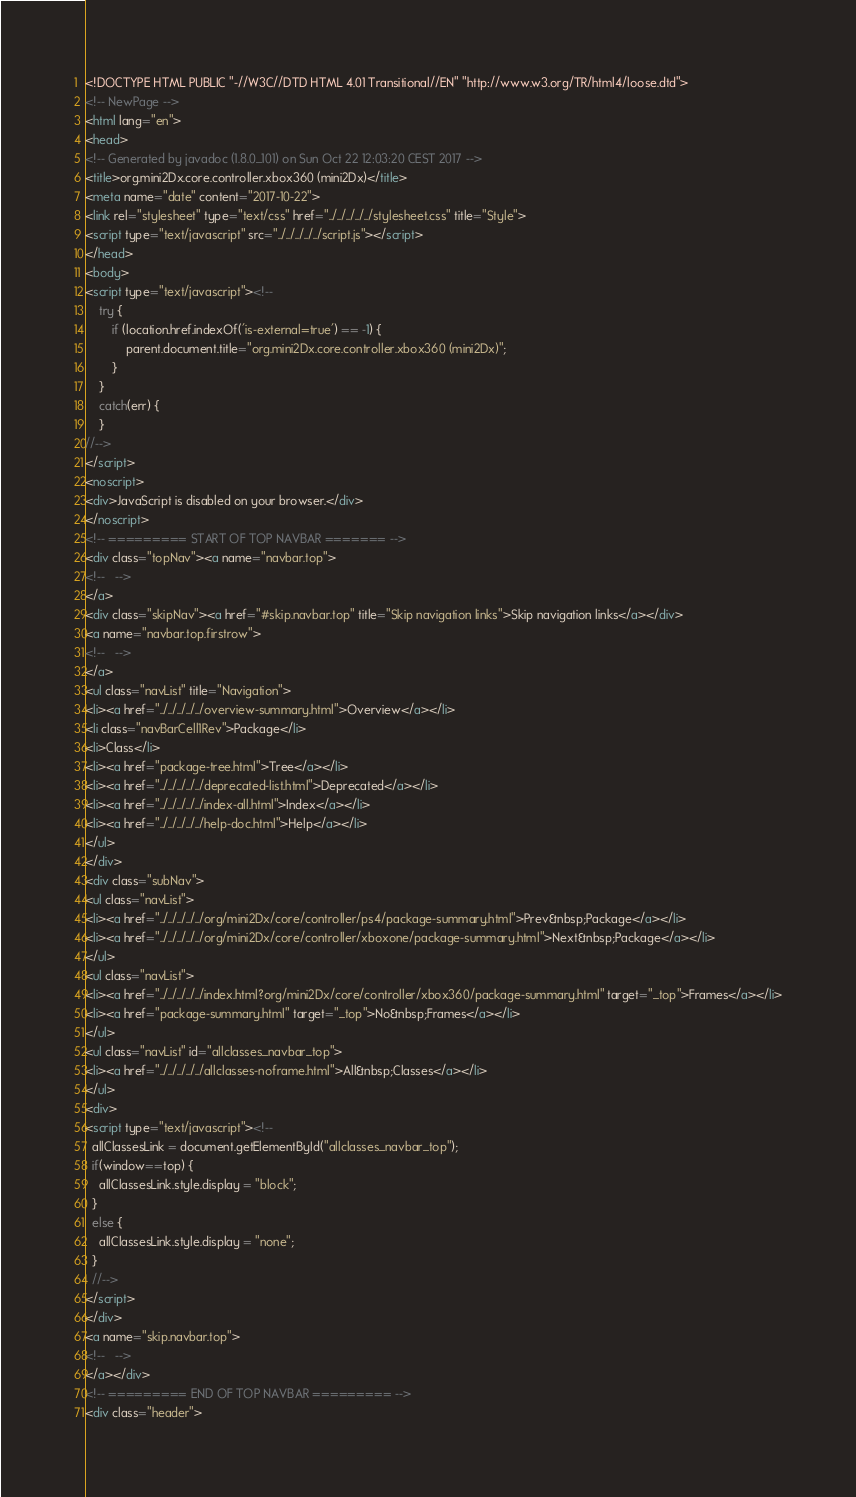<code> <loc_0><loc_0><loc_500><loc_500><_HTML_><!DOCTYPE HTML PUBLIC "-//W3C//DTD HTML 4.01 Transitional//EN" "http://www.w3.org/TR/html4/loose.dtd">
<!-- NewPage -->
<html lang="en">
<head>
<!-- Generated by javadoc (1.8.0_101) on Sun Oct 22 12:03:20 CEST 2017 -->
<title>org.mini2Dx.core.controller.xbox360 (mini2Dx)</title>
<meta name="date" content="2017-10-22">
<link rel="stylesheet" type="text/css" href="../../../../../stylesheet.css" title="Style">
<script type="text/javascript" src="../../../../../script.js"></script>
</head>
<body>
<script type="text/javascript"><!--
    try {
        if (location.href.indexOf('is-external=true') == -1) {
            parent.document.title="org.mini2Dx.core.controller.xbox360 (mini2Dx)";
        }
    }
    catch(err) {
    }
//-->
</script>
<noscript>
<div>JavaScript is disabled on your browser.</div>
</noscript>
<!-- ========= START OF TOP NAVBAR ======= -->
<div class="topNav"><a name="navbar.top">
<!--   -->
</a>
<div class="skipNav"><a href="#skip.navbar.top" title="Skip navigation links">Skip navigation links</a></div>
<a name="navbar.top.firstrow">
<!--   -->
</a>
<ul class="navList" title="Navigation">
<li><a href="../../../../../overview-summary.html">Overview</a></li>
<li class="navBarCell1Rev">Package</li>
<li>Class</li>
<li><a href="package-tree.html">Tree</a></li>
<li><a href="../../../../../deprecated-list.html">Deprecated</a></li>
<li><a href="../../../../../index-all.html">Index</a></li>
<li><a href="../../../../../help-doc.html">Help</a></li>
</ul>
</div>
<div class="subNav">
<ul class="navList">
<li><a href="../../../../../org/mini2Dx/core/controller/ps4/package-summary.html">Prev&nbsp;Package</a></li>
<li><a href="../../../../../org/mini2Dx/core/controller/xboxone/package-summary.html">Next&nbsp;Package</a></li>
</ul>
<ul class="navList">
<li><a href="../../../../../index.html?org/mini2Dx/core/controller/xbox360/package-summary.html" target="_top">Frames</a></li>
<li><a href="package-summary.html" target="_top">No&nbsp;Frames</a></li>
</ul>
<ul class="navList" id="allclasses_navbar_top">
<li><a href="../../../../../allclasses-noframe.html">All&nbsp;Classes</a></li>
</ul>
<div>
<script type="text/javascript"><!--
  allClassesLink = document.getElementById("allclasses_navbar_top");
  if(window==top) {
    allClassesLink.style.display = "block";
  }
  else {
    allClassesLink.style.display = "none";
  }
  //-->
</script>
</div>
<a name="skip.navbar.top">
<!--   -->
</a></div>
<!-- ========= END OF TOP NAVBAR ========= -->
<div class="header"></code> 